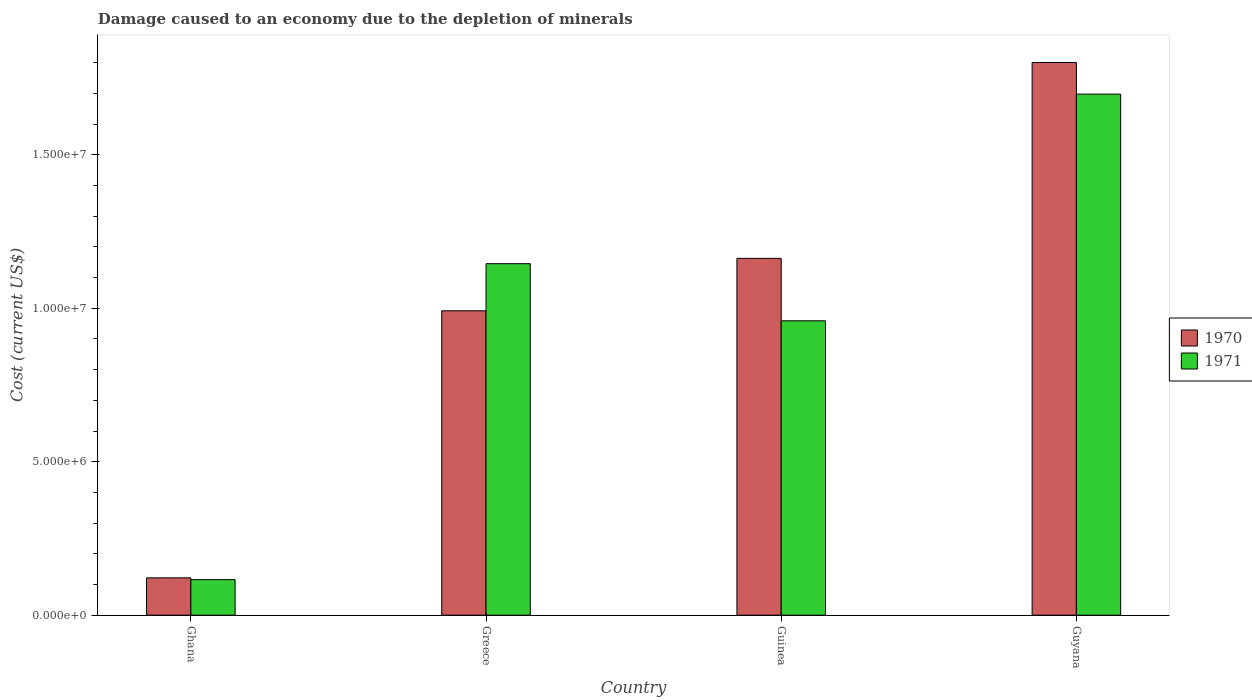How many different coloured bars are there?
Keep it short and to the point. 2. Are the number of bars per tick equal to the number of legend labels?
Your answer should be very brief. Yes. Are the number of bars on each tick of the X-axis equal?
Make the answer very short. Yes. What is the cost of damage caused due to the depletion of minerals in 1970 in Guinea?
Keep it short and to the point. 1.16e+07. Across all countries, what is the maximum cost of damage caused due to the depletion of minerals in 1971?
Provide a short and direct response. 1.70e+07. Across all countries, what is the minimum cost of damage caused due to the depletion of minerals in 1971?
Provide a succinct answer. 1.16e+06. In which country was the cost of damage caused due to the depletion of minerals in 1971 maximum?
Give a very brief answer. Guyana. What is the total cost of damage caused due to the depletion of minerals in 1971 in the graph?
Your answer should be compact. 3.92e+07. What is the difference between the cost of damage caused due to the depletion of minerals in 1971 in Ghana and that in Guinea?
Your answer should be compact. -8.43e+06. What is the difference between the cost of damage caused due to the depletion of minerals in 1971 in Ghana and the cost of damage caused due to the depletion of minerals in 1970 in Greece?
Give a very brief answer. -8.76e+06. What is the average cost of damage caused due to the depletion of minerals in 1971 per country?
Your response must be concise. 9.79e+06. What is the difference between the cost of damage caused due to the depletion of minerals of/in 1970 and cost of damage caused due to the depletion of minerals of/in 1971 in Greece?
Your answer should be compact. -1.53e+06. What is the ratio of the cost of damage caused due to the depletion of minerals in 1970 in Ghana to that in Guinea?
Your answer should be very brief. 0.1. Is the difference between the cost of damage caused due to the depletion of minerals in 1970 in Greece and Guinea greater than the difference between the cost of damage caused due to the depletion of minerals in 1971 in Greece and Guinea?
Your answer should be very brief. No. What is the difference between the highest and the second highest cost of damage caused due to the depletion of minerals in 1971?
Offer a very short reply. 5.52e+06. What is the difference between the highest and the lowest cost of damage caused due to the depletion of minerals in 1971?
Provide a short and direct response. 1.58e+07. In how many countries, is the cost of damage caused due to the depletion of minerals in 1971 greater than the average cost of damage caused due to the depletion of minerals in 1971 taken over all countries?
Offer a very short reply. 2. Is the sum of the cost of damage caused due to the depletion of minerals in 1971 in Guinea and Guyana greater than the maximum cost of damage caused due to the depletion of minerals in 1970 across all countries?
Give a very brief answer. Yes. What does the 1st bar from the left in Guinea represents?
Offer a very short reply. 1970. What does the 1st bar from the right in Guinea represents?
Your answer should be compact. 1971. Are all the bars in the graph horizontal?
Your response must be concise. No. Does the graph contain grids?
Keep it short and to the point. No. Where does the legend appear in the graph?
Ensure brevity in your answer.  Center right. How many legend labels are there?
Offer a terse response. 2. How are the legend labels stacked?
Offer a very short reply. Vertical. What is the title of the graph?
Offer a very short reply. Damage caused to an economy due to the depletion of minerals. Does "1972" appear as one of the legend labels in the graph?
Ensure brevity in your answer.  No. What is the label or title of the X-axis?
Provide a succinct answer. Country. What is the label or title of the Y-axis?
Keep it short and to the point. Cost (current US$). What is the Cost (current US$) of 1970 in Ghana?
Ensure brevity in your answer.  1.22e+06. What is the Cost (current US$) in 1971 in Ghana?
Offer a terse response. 1.16e+06. What is the Cost (current US$) in 1970 in Greece?
Make the answer very short. 9.92e+06. What is the Cost (current US$) in 1971 in Greece?
Your answer should be compact. 1.15e+07. What is the Cost (current US$) in 1970 in Guinea?
Your response must be concise. 1.16e+07. What is the Cost (current US$) of 1971 in Guinea?
Provide a succinct answer. 9.59e+06. What is the Cost (current US$) in 1970 in Guyana?
Keep it short and to the point. 1.80e+07. What is the Cost (current US$) of 1971 in Guyana?
Your response must be concise. 1.70e+07. Across all countries, what is the maximum Cost (current US$) in 1970?
Offer a very short reply. 1.80e+07. Across all countries, what is the maximum Cost (current US$) in 1971?
Keep it short and to the point. 1.70e+07. Across all countries, what is the minimum Cost (current US$) in 1970?
Your answer should be very brief. 1.22e+06. Across all countries, what is the minimum Cost (current US$) in 1971?
Keep it short and to the point. 1.16e+06. What is the total Cost (current US$) of 1970 in the graph?
Give a very brief answer. 4.08e+07. What is the total Cost (current US$) of 1971 in the graph?
Keep it short and to the point. 3.92e+07. What is the difference between the Cost (current US$) of 1970 in Ghana and that in Greece?
Offer a very short reply. -8.70e+06. What is the difference between the Cost (current US$) of 1971 in Ghana and that in Greece?
Keep it short and to the point. -1.03e+07. What is the difference between the Cost (current US$) of 1970 in Ghana and that in Guinea?
Your answer should be compact. -1.04e+07. What is the difference between the Cost (current US$) of 1971 in Ghana and that in Guinea?
Ensure brevity in your answer.  -8.43e+06. What is the difference between the Cost (current US$) of 1970 in Ghana and that in Guyana?
Give a very brief answer. -1.68e+07. What is the difference between the Cost (current US$) in 1971 in Ghana and that in Guyana?
Make the answer very short. -1.58e+07. What is the difference between the Cost (current US$) in 1970 in Greece and that in Guinea?
Provide a succinct answer. -1.71e+06. What is the difference between the Cost (current US$) in 1971 in Greece and that in Guinea?
Provide a short and direct response. 1.86e+06. What is the difference between the Cost (current US$) in 1970 in Greece and that in Guyana?
Give a very brief answer. -8.09e+06. What is the difference between the Cost (current US$) in 1971 in Greece and that in Guyana?
Make the answer very short. -5.52e+06. What is the difference between the Cost (current US$) in 1970 in Guinea and that in Guyana?
Offer a terse response. -6.38e+06. What is the difference between the Cost (current US$) of 1971 in Guinea and that in Guyana?
Make the answer very short. -7.38e+06. What is the difference between the Cost (current US$) in 1970 in Ghana and the Cost (current US$) in 1971 in Greece?
Make the answer very short. -1.02e+07. What is the difference between the Cost (current US$) in 1970 in Ghana and the Cost (current US$) in 1971 in Guinea?
Offer a very short reply. -8.37e+06. What is the difference between the Cost (current US$) in 1970 in Ghana and the Cost (current US$) in 1971 in Guyana?
Keep it short and to the point. -1.58e+07. What is the difference between the Cost (current US$) of 1970 in Greece and the Cost (current US$) of 1971 in Guinea?
Your answer should be very brief. 3.26e+05. What is the difference between the Cost (current US$) of 1970 in Greece and the Cost (current US$) of 1971 in Guyana?
Provide a short and direct response. -7.06e+06. What is the difference between the Cost (current US$) of 1970 in Guinea and the Cost (current US$) of 1971 in Guyana?
Your answer should be compact. -5.35e+06. What is the average Cost (current US$) of 1970 per country?
Your answer should be very brief. 1.02e+07. What is the average Cost (current US$) in 1971 per country?
Offer a terse response. 9.79e+06. What is the difference between the Cost (current US$) in 1970 and Cost (current US$) in 1971 in Ghana?
Ensure brevity in your answer.  5.86e+04. What is the difference between the Cost (current US$) in 1970 and Cost (current US$) in 1971 in Greece?
Provide a succinct answer. -1.53e+06. What is the difference between the Cost (current US$) of 1970 and Cost (current US$) of 1971 in Guinea?
Offer a terse response. 2.03e+06. What is the difference between the Cost (current US$) of 1970 and Cost (current US$) of 1971 in Guyana?
Ensure brevity in your answer.  1.03e+06. What is the ratio of the Cost (current US$) of 1970 in Ghana to that in Greece?
Give a very brief answer. 0.12. What is the ratio of the Cost (current US$) of 1971 in Ghana to that in Greece?
Provide a succinct answer. 0.1. What is the ratio of the Cost (current US$) of 1970 in Ghana to that in Guinea?
Keep it short and to the point. 0.1. What is the ratio of the Cost (current US$) in 1971 in Ghana to that in Guinea?
Offer a terse response. 0.12. What is the ratio of the Cost (current US$) in 1970 in Ghana to that in Guyana?
Offer a very short reply. 0.07. What is the ratio of the Cost (current US$) in 1971 in Ghana to that in Guyana?
Ensure brevity in your answer.  0.07. What is the ratio of the Cost (current US$) of 1970 in Greece to that in Guinea?
Provide a short and direct response. 0.85. What is the ratio of the Cost (current US$) in 1971 in Greece to that in Guinea?
Make the answer very short. 1.19. What is the ratio of the Cost (current US$) of 1970 in Greece to that in Guyana?
Keep it short and to the point. 0.55. What is the ratio of the Cost (current US$) in 1971 in Greece to that in Guyana?
Offer a very short reply. 0.67. What is the ratio of the Cost (current US$) in 1970 in Guinea to that in Guyana?
Offer a very short reply. 0.65. What is the ratio of the Cost (current US$) in 1971 in Guinea to that in Guyana?
Ensure brevity in your answer.  0.56. What is the difference between the highest and the second highest Cost (current US$) in 1970?
Your response must be concise. 6.38e+06. What is the difference between the highest and the second highest Cost (current US$) in 1971?
Your answer should be compact. 5.52e+06. What is the difference between the highest and the lowest Cost (current US$) of 1970?
Give a very brief answer. 1.68e+07. What is the difference between the highest and the lowest Cost (current US$) of 1971?
Provide a short and direct response. 1.58e+07. 